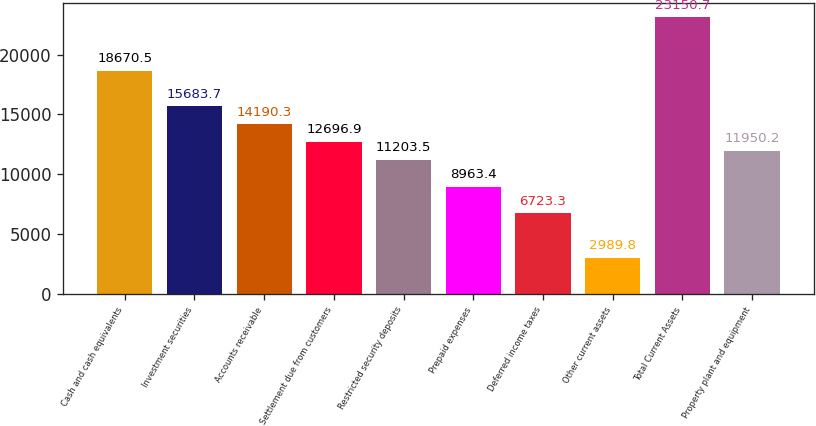Convert chart to OTSL. <chart><loc_0><loc_0><loc_500><loc_500><bar_chart><fcel>Cash and cash equivalents<fcel>Investment securities<fcel>Accounts receivable<fcel>Settlement due from customers<fcel>Restricted security deposits<fcel>Prepaid expenses<fcel>Deferred income taxes<fcel>Other current assets<fcel>Total Current Assets<fcel>Property plant and equipment<nl><fcel>18670.5<fcel>15683.7<fcel>14190.3<fcel>12696.9<fcel>11203.5<fcel>8963.4<fcel>6723.3<fcel>2989.8<fcel>23150.7<fcel>11950.2<nl></chart> 